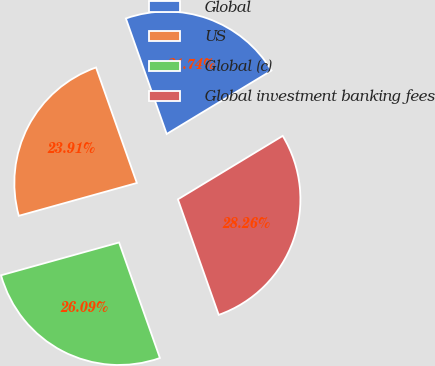Convert chart. <chart><loc_0><loc_0><loc_500><loc_500><pie_chart><fcel>Global<fcel>US<fcel>Global (c)<fcel>Global investment banking fees<nl><fcel>21.74%<fcel>23.91%<fcel>26.09%<fcel>28.26%<nl></chart> 